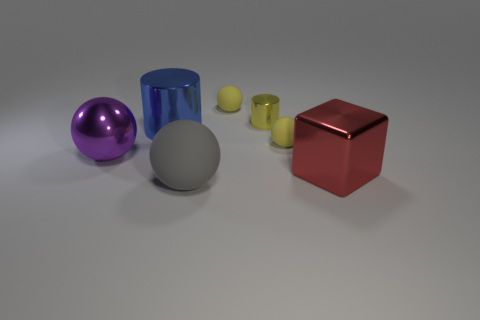What is the size of the gray rubber thing that is the same shape as the large purple object?
Offer a very short reply. Large. Are there more yellow shiny objects than tiny red metal cylinders?
Provide a succinct answer. Yes. Is the red object the same shape as the tiny yellow metal thing?
Make the answer very short. No. There is a ball that is on the left side of the object that is in front of the large red block; what is it made of?
Ensure brevity in your answer.  Metal. Is the gray rubber ball the same size as the blue shiny cylinder?
Your answer should be very brief. Yes. There is a sphere that is to the left of the big matte sphere; is there a red cube behind it?
Make the answer very short. No. What shape is the yellow thing that is on the left side of the tiny metal cylinder?
Give a very brief answer. Sphere. How many metallic cylinders are in front of the metallic cylinder that is left of the rubber object in front of the metallic block?
Ensure brevity in your answer.  0. There is a yellow shiny object; is its size the same as the object in front of the shiny block?
Offer a very short reply. No. How big is the red block that is on the right side of the sphere behind the small yellow metallic cylinder?
Ensure brevity in your answer.  Large. 